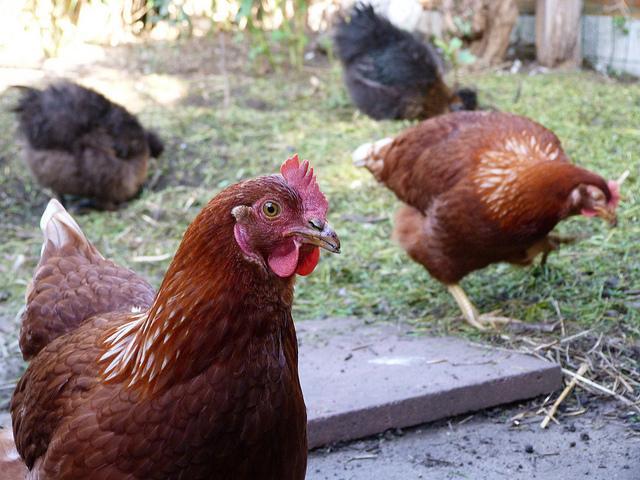How many chickens?
Give a very brief answer. 4. How many birds can you see?
Give a very brief answer. 4. 